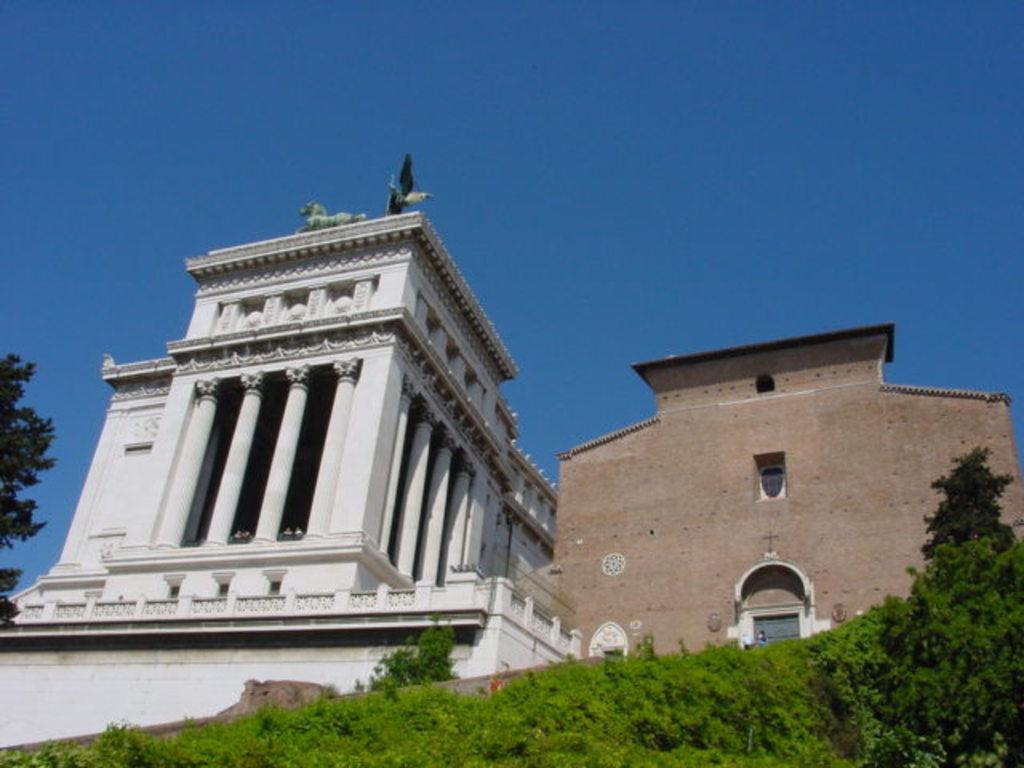Could you give a brief overview of what you see in this image? At the bottom of the picture, we see grass and a tree. Beside that, we see a building in brown color. I think it is a church. Beside that, we see a building in white color. On the left side, we see a tree. At the top of the picture, we see the sky, which is blue in color. 